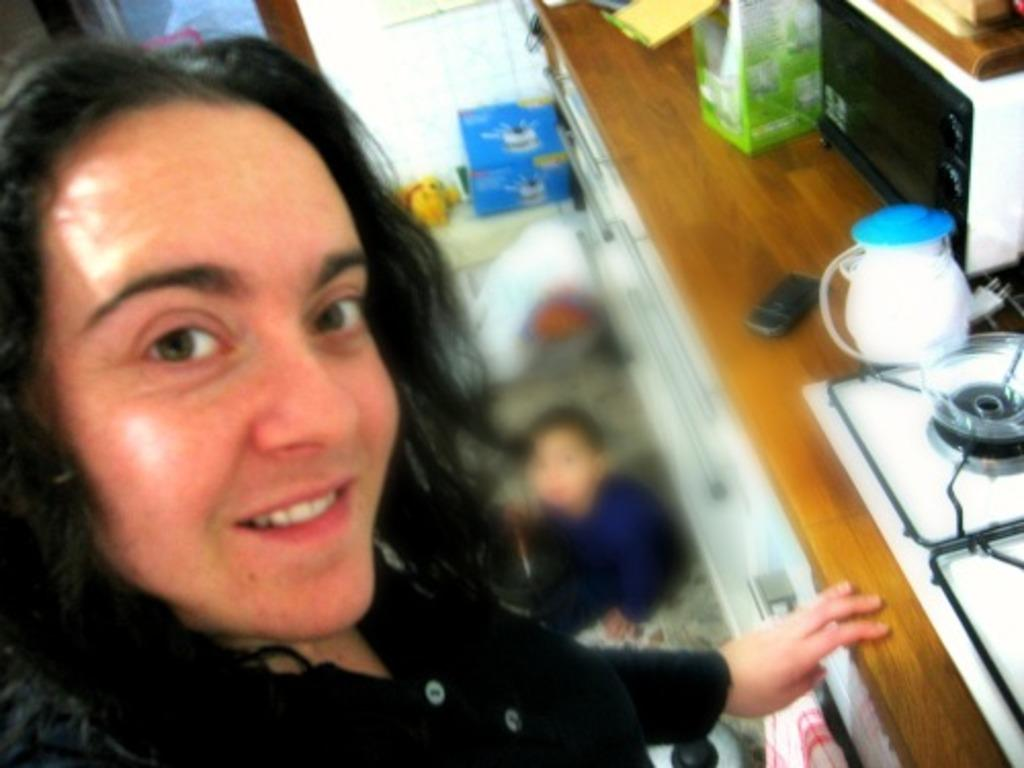What is the person in the image doing? The person in the image is taking a picture. What cooking appliances can be seen in the image? There is a stove and an oven in the image. What electronic device is present in the image? There is a mobile in the image. What other objects are on the desk besides the stove and oven? There are other objects on the desk, but their specific details are not mentioned in the facts. What is the child on the floor doing? The facts do not mention what the child is doing on the floor. What is the rate of magic emitted by the apparatus in the image? There is no mention of magic or an apparatus in the image. The image features a person taking a picture, a stove, an oven, a mobile, and a child on the floor. 